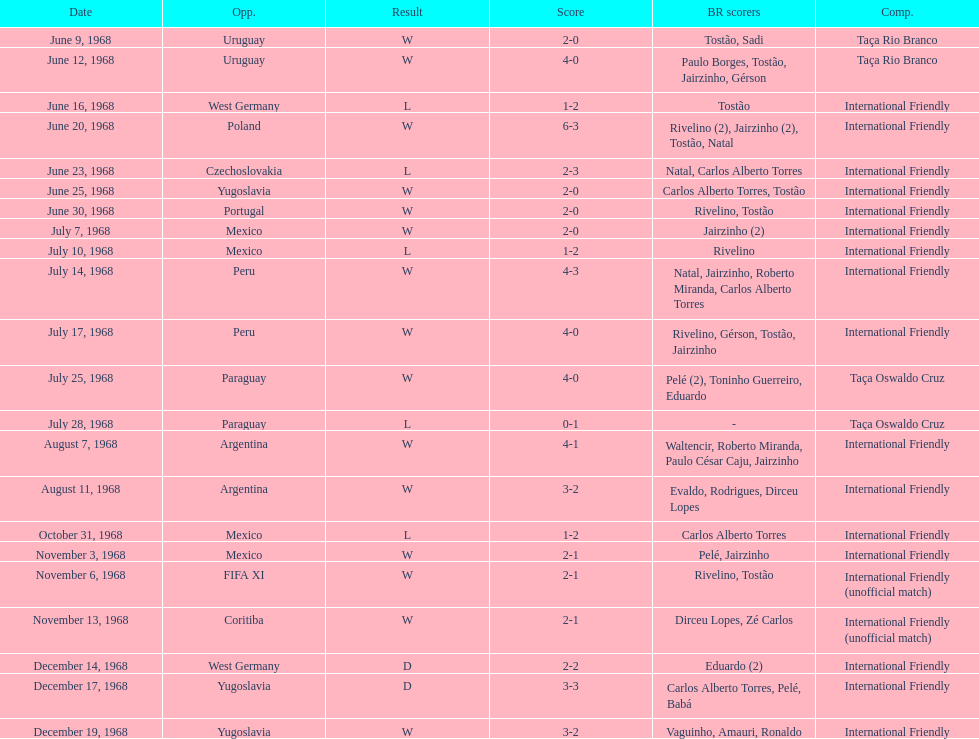How many times did brazil play against argentina in the international friendly competition? 2. 